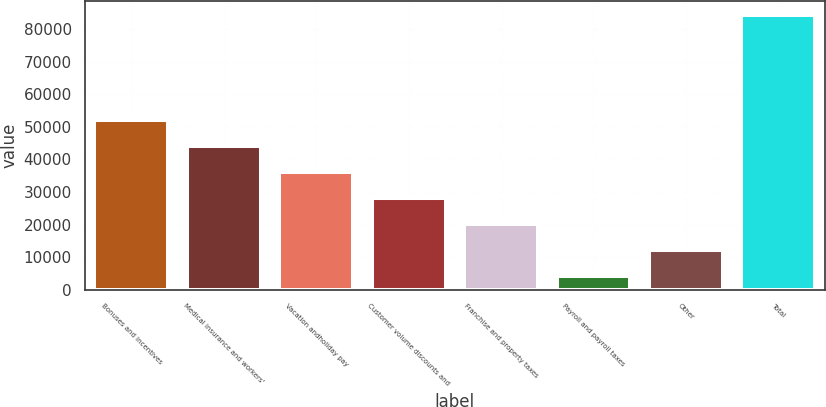Convert chart to OTSL. <chart><loc_0><loc_0><loc_500><loc_500><bar_chart><fcel>Bonuses and incentives<fcel>Medical insurance and workers'<fcel>Vacation andholiday pay<fcel>Customer volume discounts and<fcel>Franchise and property taxes<fcel>Payroll and payroll taxes<fcel>Other<fcel>Total<nl><fcel>52269.2<fcel>44238.5<fcel>36207.8<fcel>28177.1<fcel>20146.4<fcel>4085<fcel>12115.7<fcel>84392<nl></chart> 